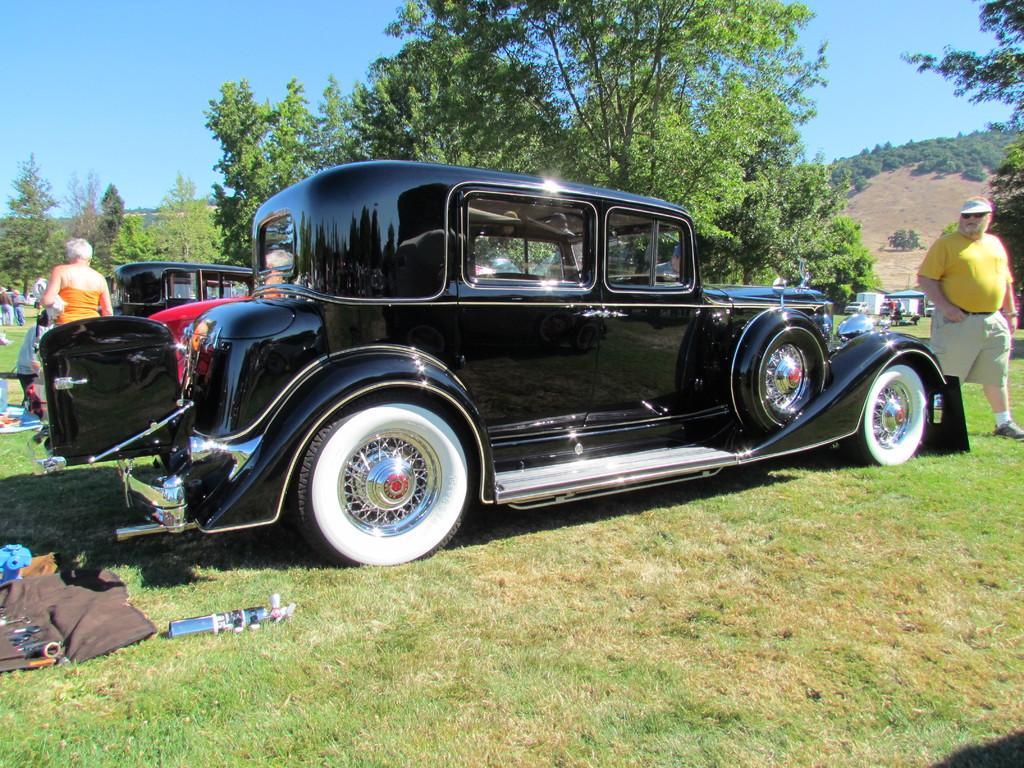How would you summarize this image in a sentence or two? In this image in the front there's grass on the ground. In the center there are cars and there are persons and on the left side there are objects which are brown and green colour on the ground. In the background there are trees and there are persons. 